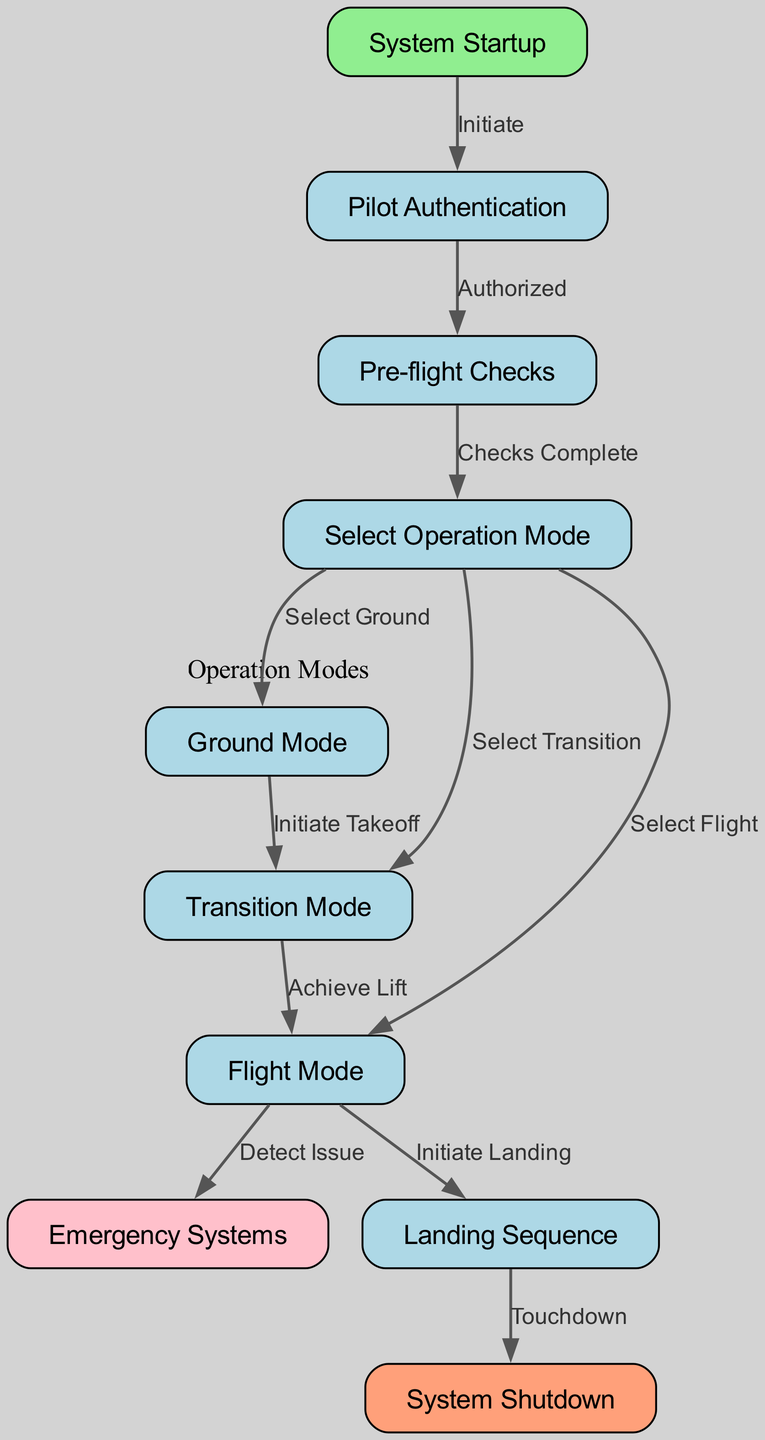What is the first step in the process? The first step in the flowchart is "System Startup," which is the starting point of the entire operation sequence.
Answer: System Startup How many modes can be selected? There are three modes indicated in the diagram: Ground Mode, Transition Mode, and Flight Mode.
Answer: Three What is the condition to move from authentication to pre-flight checks? The condition is labeled "Authorized," meaning the pilot must be authenticated before proceeding to the pre-flight checks.
Answer: Authorized What happens after the "Flight Mode" if an issue is detected? If an issue is detected during Flight Mode, the flow transitions to "Emergency Systems." This indicates that emergency protocols will be activated in response to the issue.
Answer: Emergency Systems What indicates the transition from Ground Mode to Transition Mode? The transition from Ground Mode to Transition Mode is indicated by the action "Initiate Takeoff." This means that once takeoff is initiated, the next logical step is to transition.
Answer: Initiate Takeoff If the landing sequence is initiated, what happens next? After the landing sequence is initiated, the next step is "Touchdown," which indicates that the flying car is preparing to land and complete its operation safely.
Answer: Touchdown How many total edges/connections are in the diagram? There are eleven edges connecting various nodes, showing the relationships between the steps in the system operations.
Answer: Eleven Which node is highlighted in pink, and what is its significance? The node highlighted in pink is "Emergency Systems," indicating its importance in the flowchart as a critical response action when issues are detected during flight.
Answer: Emergency Systems What mode must be selected to proceed to the "Landing Sequence"? To proceed to the "Landing Sequence," the current mode must be "Flight Mode." This indicates that the flying car is in the air and preparing for landing.
Answer: Flight Mode 